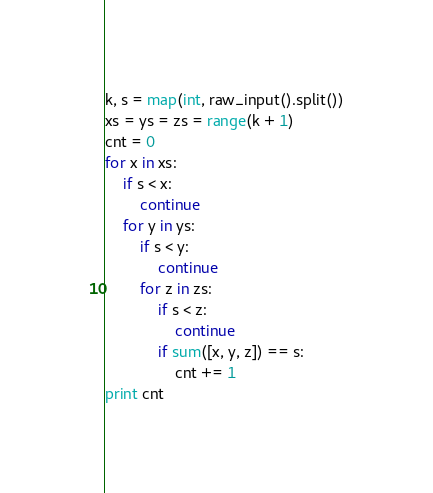<code> <loc_0><loc_0><loc_500><loc_500><_Python_>k, s = map(int, raw_input().split())
xs = ys = zs = range(k + 1)
cnt = 0
for x in xs:
    if s < x:
        continue
    for y in ys:
        if s < y:
            continue
        for z in zs:
            if s < z:
                continue
            if sum([x, y, z]) == s:
                cnt += 1
print cnt</code> 